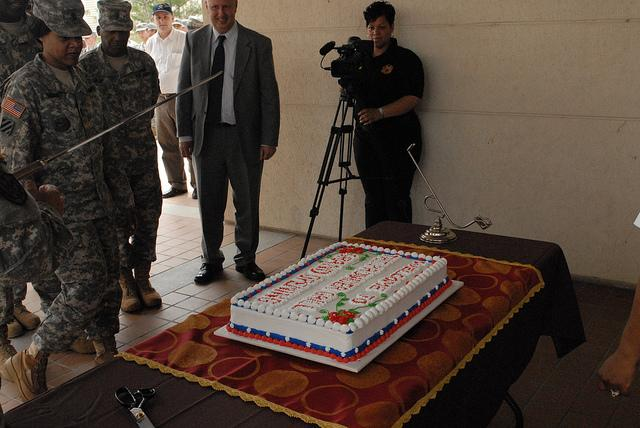What message does this cake send to those that see it? welcome 